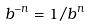<formula> <loc_0><loc_0><loc_500><loc_500>b ^ { - n } = 1 / b ^ { n }</formula> 